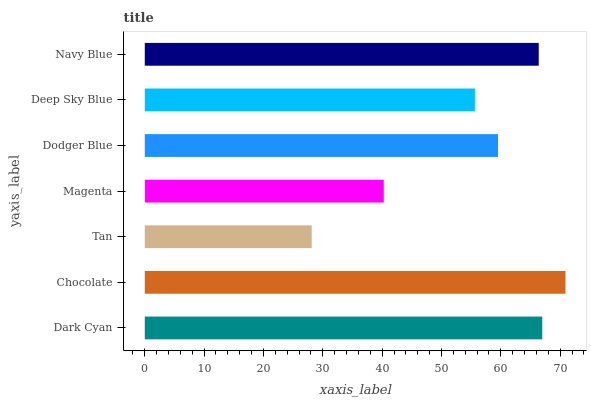Is Tan the minimum?
Answer yes or no. Yes. Is Chocolate the maximum?
Answer yes or no. Yes. Is Chocolate the minimum?
Answer yes or no. No. Is Tan the maximum?
Answer yes or no. No. Is Chocolate greater than Tan?
Answer yes or no. Yes. Is Tan less than Chocolate?
Answer yes or no. Yes. Is Tan greater than Chocolate?
Answer yes or no. No. Is Chocolate less than Tan?
Answer yes or no. No. Is Dodger Blue the high median?
Answer yes or no. Yes. Is Dodger Blue the low median?
Answer yes or no. Yes. Is Navy Blue the high median?
Answer yes or no. No. Is Chocolate the low median?
Answer yes or no. No. 